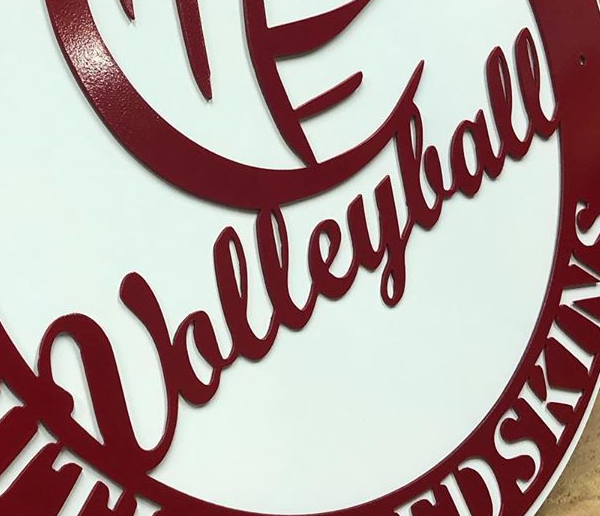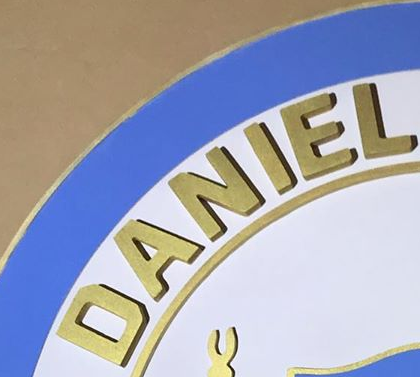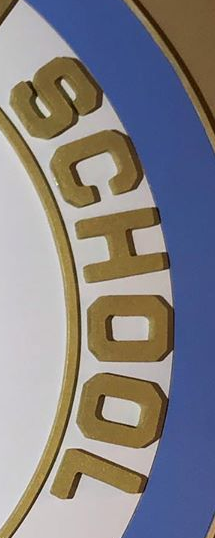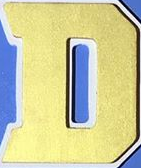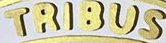What text appears in these images from left to right, separated by a semicolon? Ualleylall; DANIEL; SCHOOL; D; TRIBUS 